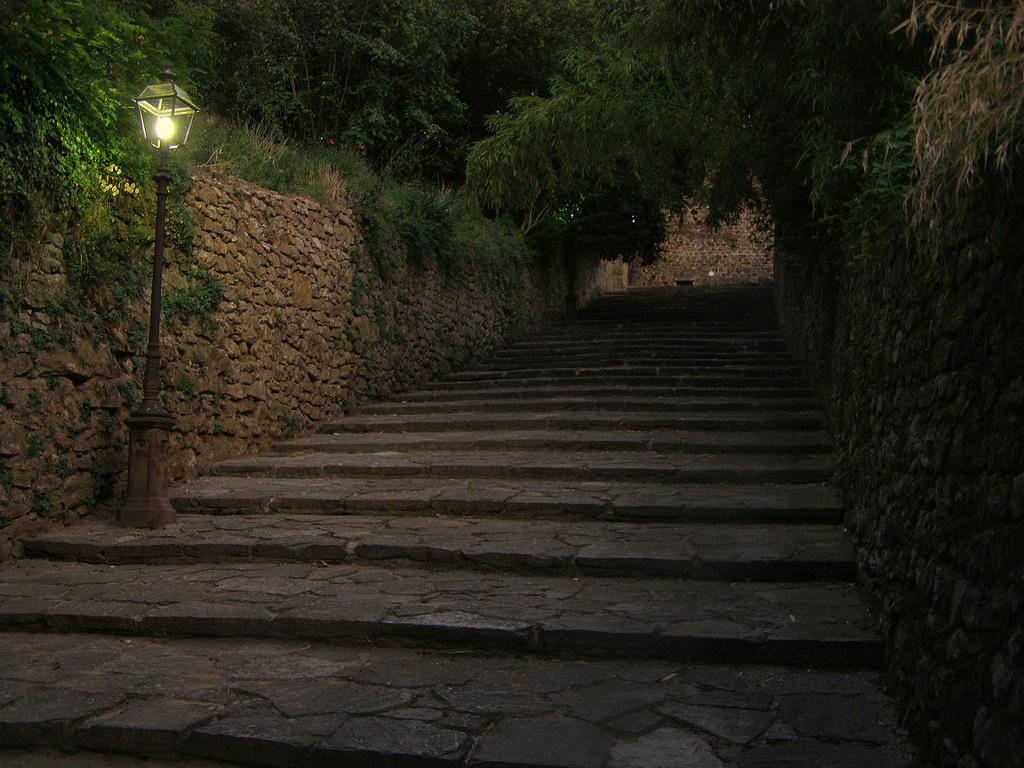Describe this image in one or two sentences. This image is taken during night time. In this image we can see a light pole. We can also see the stairs, trees, grass and also the stone wall. 